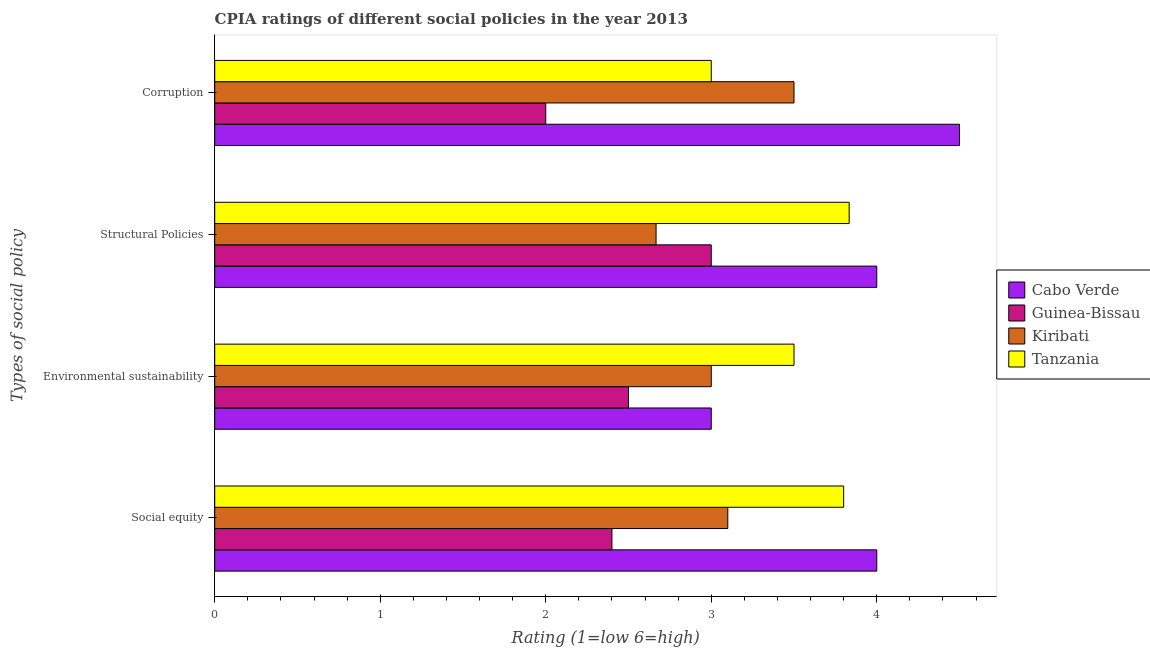Are the number of bars on each tick of the Y-axis equal?
Give a very brief answer. Yes. How many bars are there on the 2nd tick from the top?
Your answer should be very brief. 4. What is the label of the 2nd group of bars from the top?
Provide a succinct answer. Structural Policies. Across all countries, what is the minimum cpia rating of environmental sustainability?
Offer a terse response. 2.5. In which country was the cpia rating of social equity maximum?
Your answer should be compact. Cabo Verde. In which country was the cpia rating of structural policies minimum?
Provide a succinct answer. Kiribati. What is the total cpia rating of structural policies in the graph?
Your answer should be very brief. 13.5. What is the difference between the cpia rating of corruption in Kiribati and that in Cabo Verde?
Provide a succinct answer. -1. What is the difference between the cpia rating of environmental sustainability in Tanzania and the cpia rating of social equity in Guinea-Bissau?
Your response must be concise. 1.1. What is the average cpia rating of structural policies per country?
Your response must be concise. 3.37. What is the difference between the cpia rating of structural policies and cpia rating of social equity in Kiribati?
Offer a terse response. -0.43. What is the ratio of the cpia rating of social equity in Kiribati to that in Tanzania?
Your answer should be very brief. 0.82. What is the difference between the highest and the second highest cpia rating of structural policies?
Keep it short and to the point. 0.17. What is the difference between the highest and the lowest cpia rating of structural policies?
Offer a terse response. 1.33. Is the sum of the cpia rating of social equity in Cabo Verde and Kiribati greater than the maximum cpia rating of corruption across all countries?
Your answer should be very brief. Yes. Is it the case that in every country, the sum of the cpia rating of corruption and cpia rating of environmental sustainability is greater than the sum of cpia rating of structural policies and cpia rating of social equity?
Make the answer very short. No. What does the 2nd bar from the top in Social equity represents?
Offer a very short reply. Kiribati. What does the 3rd bar from the bottom in Structural Policies represents?
Your answer should be very brief. Kiribati. Are all the bars in the graph horizontal?
Ensure brevity in your answer.  Yes. Are the values on the major ticks of X-axis written in scientific E-notation?
Your response must be concise. No. Does the graph contain any zero values?
Your response must be concise. No. Does the graph contain grids?
Make the answer very short. No. How many legend labels are there?
Offer a terse response. 4. How are the legend labels stacked?
Make the answer very short. Vertical. What is the title of the graph?
Make the answer very short. CPIA ratings of different social policies in the year 2013. Does "Barbados" appear as one of the legend labels in the graph?
Keep it short and to the point. No. What is the label or title of the Y-axis?
Your answer should be very brief. Types of social policy. What is the Rating (1=low 6=high) in Kiribati in Social equity?
Give a very brief answer. 3.1. What is the Rating (1=low 6=high) of Guinea-Bissau in Environmental sustainability?
Provide a short and direct response. 2.5. What is the Rating (1=low 6=high) in Tanzania in Environmental sustainability?
Ensure brevity in your answer.  3.5. What is the Rating (1=low 6=high) in Cabo Verde in Structural Policies?
Offer a very short reply. 4. What is the Rating (1=low 6=high) in Kiribati in Structural Policies?
Give a very brief answer. 2.67. What is the Rating (1=low 6=high) of Tanzania in Structural Policies?
Give a very brief answer. 3.83. What is the Rating (1=low 6=high) in Guinea-Bissau in Corruption?
Your answer should be very brief. 2. What is the Rating (1=low 6=high) in Tanzania in Corruption?
Ensure brevity in your answer.  3. Across all Types of social policy, what is the maximum Rating (1=low 6=high) of Cabo Verde?
Offer a terse response. 4.5. Across all Types of social policy, what is the maximum Rating (1=low 6=high) of Guinea-Bissau?
Your answer should be compact. 3. Across all Types of social policy, what is the maximum Rating (1=low 6=high) in Tanzania?
Offer a very short reply. 3.83. Across all Types of social policy, what is the minimum Rating (1=low 6=high) in Cabo Verde?
Keep it short and to the point. 3. Across all Types of social policy, what is the minimum Rating (1=low 6=high) of Kiribati?
Your response must be concise. 2.67. Across all Types of social policy, what is the minimum Rating (1=low 6=high) in Tanzania?
Your answer should be compact. 3. What is the total Rating (1=low 6=high) in Cabo Verde in the graph?
Offer a very short reply. 15.5. What is the total Rating (1=low 6=high) of Kiribati in the graph?
Provide a succinct answer. 12.27. What is the total Rating (1=low 6=high) in Tanzania in the graph?
Offer a very short reply. 14.13. What is the difference between the Rating (1=low 6=high) of Cabo Verde in Social equity and that in Environmental sustainability?
Provide a succinct answer. 1. What is the difference between the Rating (1=low 6=high) in Guinea-Bissau in Social equity and that in Environmental sustainability?
Provide a short and direct response. -0.1. What is the difference between the Rating (1=low 6=high) of Cabo Verde in Social equity and that in Structural Policies?
Your answer should be compact. 0. What is the difference between the Rating (1=low 6=high) in Guinea-Bissau in Social equity and that in Structural Policies?
Your answer should be very brief. -0.6. What is the difference between the Rating (1=low 6=high) in Kiribati in Social equity and that in Structural Policies?
Offer a terse response. 0.43. What is the difference between the Rating (1=low 6=high) of Tanzania in Social equity and that in Structural Policies?
Provide a short and direct response. -0.03. What is the difference between the Rating (1=low 6=high) in Kiribati in Social equity and that in Corruption?
Offer a terse response. -0.4. What is the difference between the Rating (1=low 6=high) of Guinea-Bissau in Environmental sustainability and that in Structural Policies?
Your answer should be compact. -0.5. What is the difference between the Rating (1=low 6=high) in Kiribati in Environmental sustainability and that in Structural Policies?
Your response must be concise. 0.33. What is the difference between the Rating (1=low 6=high) in Cabo Verde in Environmental sustainability and that in Corruption?
Make the answer very short. -1.5. What is the difference between the Rating (1=low 6=high) of Guinea-Bissau in Environmental sustainability and that in Corruption?
Your response must be concise. 0.5. What is the difference between the Rating (1=low 6=high) of Guinea-Bissau in Structural Policies and that in Corruption?
Keep it short and to the point. 1. What is the difference between the Rating (1=low 6=high) in Cabo Verde in Social equity and the Rating (1=low 6=high) in Guinea-Bissau in Environmental sustainability?
Your answer should be very brief. 1.5. What is the difference between the Rating (1=low 6=high) of Guinea-Bissau in Social equity and the Rating (1=low 6=high) of Kiribati in Environmental sustainability?
Your answer should be compact. -0.6. What is the difference between the Rating (1=low 6=high) in Kiribati in Social equity and the Rating (1=low 6=high) in Tanzania in Environmental sustainability?
Your answer should be very brief. -0.4. What is the difference between the Rating (1=low 6=high) in Cabo Verde in Social equity and the Rating (1=low 6=high) in Guinea-Bissau in Structural Policies?
Your response must be concise. 1. What is the difference between the Rating (1=low 6=high) in Cabo Verde in Social equity and the Rating (1=low 6=high) in Kiribati in Structural Policies?
Provide a succinct answer. 1.33. What is the difference between the Rating (1=low 6=high) in Cabo Verde in Social equity and the Rating (1=low 6=high) in Tanzania in Structural Policies?
Offer a very short reply. 0.17. What is the difference between the Rating (1=low 6=high) of Guinea-Bissau in Social equity and the Rating (1=low 6=high) of Kiribati in Structural Policies?
Provide a succinct answer. -0.27. What is the difference between the Rating (1=low 6=high) of Guinea-Bissau in Social equity and the Rating (1=low 6=high) of Tanzania in Structural Policies?
Keep it short and to the point. -1.43. What is the difference between the Rating (1=low 6=high) in Kiribati in Social equity and the Rating (1=low 6=high) in Tanzania in Structural Policies?
Provide a short and direct response. -0.73. What is the difference between the Rating (1=low 6=high) of Cabo Verde in Social equity and the Rating (1=low 6=high) of Guinea-Bissau in Corruption?
Give a very brief answer. 2. What is the difference between the Rating (1=low 6=high) in Cabo Verde in Social equity and the Rating (1=low 6=high) in Tanzania in Corruption?
Your answer should be compact. 1. What is the difference between the Rating (1=low 6=high) in Guinea-Bissau in Environmental sustainability and the Rating (1=low 6=high) in Kiribati in Structural Policies?
Keep it short and to the point. -0.17. What is the difference between the Rating (1=low 6=high) in Guinea-Bissau in Environmental sustainability and the Rating (1=low 6=high) in Tanzania in Structural Policies?
Make the answer very short. -1.33. What is the difference between the Rating (1=low 6=high) of Kiribati in Environmental sustainability and the Rating (1=low 6=high) of Tanzania in Structural Policies?
Provide a succinct answer. -0.83. What is the difference between the Rating (1=low 6=high) in Cabo Verde in Environmental sustainability and the Rating (1=low 6=high) in Kiribati in Corruption?
Offer a very short reply. -0.5. What is the difference between the Rating (1=low 6=high) of Cabo Verde in Structural Policies and the Rating (1=low 6=high) of Guinea-Bissau in Corruption?
Offer a terse response. 2. What is the average Rating (1=low 6=high) of Cabo Verde per Types of social policy?
Your answer should be compact. 3.88. What is the average Rating (1=low 6=high) of Guinea-Bissau per Types of social policy?
Provide a succinct answer. 2.48. What is the average Rating (1=low 6=high) in Kiribati per Types of social policy?
Offer a very short reply. 3.07. What is the average Rating (1=low 6=high) in Tanzania per Types of social policy?
Keep it short and to the point. 3.53. What is the difference between the Rating (1=low 6=high) in Cabo Verde and Rating (1=low 6=high) in Kiribati in Social equity?
Provide a short and direct response. 0.9. What is the difference between the Rating (1=low 6=high) of Cabo Verde and Rating (1=low 6=high) of Tanzania in Social equity?
Provide a short and direct response. 0.2. What is the difference between the Rating (1=low 6=high) of Guinea-Bissau and Rating (1=low 6=high) of Kiribati in Social equity?
Ensure brevity in your answer.  -0.7. What is the difference between the Rating (1=low 6=high) of Guinea-Bissau and Rating (1=low 6=high) of Tanzania in Social equity?
Give a very brief answer. -1.4. What is the difference between the Rating (1=low 6=high) in Kiribati and Rating (1=low 6=high) in Tanzania in Social equity?
Offer a very short reply. -0.7. What is the difference between the Rating (1=low 6=high) in Cabo Verde and Rating (1=low 6=high) in Tanzania in Environmental sustainability?
Ensure brevity in your answer.  -0.5. What is the difference between the Rating (1=low 6=high) of Guinea-Bissau and Rating (1=low 6=high) of Kiribati in Environmental sustainability?
Offer a terse response. -0.5. What is the difference between the Rating (1=low 6=high) in Kiribati and Rating (1=low 6=high) in Tanzania in Environmental sustainability?
Your answer should be compact. -0.5. What is the difference between the Rating (1=low 6=high) in Cabo Verde and Rating (1=low 6=high) in Guinea-Bissau in Structural Policies?
Give a very brief answer. 1. What is the difference between the Rating (1=low 6=high) in Cabo Verde and Rating (1=low 6=high) in Kiribati in Structural Policies?
Make the answer very short. 1.33. What is the difference between the Rating (1=low 6=high) in Guinea-Bissau and Rating (1=low 6=high) in Tanzania in Structural Policies?
Provide a succinct answer. -0.83. What is the difference between the Rating (1=low 6=high) of Kiribati and Rating (1=low 6=high) of Tanzania in Structural Policies?
Make the answer very short. -1.17. What is the difference between the Rating (1=low 6=high) in Cabo Verde and Rating (1=low 6=high) in Guinea-Bissau in Corruption?
Provide a succinct answer. 2.5. What is the difference between the Rating (1=low 6=high) in Cabo Verde and Rating (1=low 6=high) in Kiribati in Corruption?
Offer a terse response. 1. What is the difference between the Rating (1=low 6=high) in Cabo Verde and Rating (1=low 6=high) in Tanzania in Corruption?
Ensure brevity in your answer.  1.5. What is the difference between the Rating (1=low 6=high) of Guinea-Bissau and Rating (1=low 6=high) of Kiribati in Corruption?
Your answer should be very brief. -1.5. What is the difference between the Rating (1=low 6=high) of Guinea-Bissau and Rating (1=low 6=high) of Tanzania in Corruption?
Make the answer very short. -1. What is the difference between the Rating (1=low 6=high) of Kiribati and Rating (1=low 6=high) of Tanzania in Corruption?
Keep it short and to the point. 0.5. What is the ratio of the Rating (1=low 6=high) of Tanzania in Social equity to that in Environmental sustainability?
Provide a short and direct response. 1.09. What is the ratio of the Rating (1=low 6=high) of Kiribati in Social equity to that in Structural Policies?
Offer a terse response. 1.16. What is the ratio of the Rating (1=low 6=high) of Tanzania in Social equity to that in Structural Policies?
Keep it short and to the point. 0.99. What is the ratio of the Rating (1=low 6=high) in Cabo Verde in Social equity to that in Corruption?
Provide a succinct answer. 0.89. What is the ratio of the Rating (1=low 6=high) in Kiribati in Social equity to that in Corruption?
Your answer should be compact. 0.89. What is the ratio of the Rating (1=low 6=high) in Tanzania in Social equity to that in Corruption?
Make the answer very short. 1.27. What is the ratio of the Rating (1=low 6=high) of Cabo Verde in Environmental sustainability to that in Structural Policies?
Ensure brevity in your answer.  0.75. What is the ratio of the Rating (1=low 6=high) in Kiribati in Environmental sustainability to that in Structural Policies?
Provide a succinct answer. 1.12. What is the ratio of the Rating (1=low 6=high) in Guinea-Bissau in Environmental sustainability to that in Corruption?
Give a very brief answer. 1.25. What is the ratio of the Rating (1=low 6=high) of Kiribati in Environmental sustainability to that in Corruption?
Your response must be concise. 0.86. What is the ratio of the Rating (1=low 6=high) in Tanzania in Environmental sustainability to that in Corruption?
Provide a succinct answer. 1.17. What is the ratio of the Rating (1=low 6=high) in Cabo Verde in Structural Policies to that in Corruption?
Provide a succinct answer. 0.89. What is the ratio of the Rating (1=low 6=high) of Guinea-Bissau in Structural Policies to that in Corruption?
Your answer should be compact. 1.5. What is the ratio of the Rating (1=low 6=high) in Kiribati in Structural Policies to that in Corruption?
Offer a terse response. 0.76. What is the ratio of the Rating (1=low 6=high) in Tanzania in Structural Policies to that in Corruption?
Keep it short and to the point. 1.28. What is the difference between the highest and the second highest Rating (1=low 6=high) of Cabo Verde?
Give a very brief answer. 0.5. What is the difference between the highest and the second highest Rating (1=low 6=high) of Guinea-Bissau?
Offer a terse response. 0.5. What is the difference between the highest and the second highest Rating (1=low 6=high) of Kiribati?
Provide a short and direct response. 0.4. What is the difference between the highest and the lowest Rating (1=low 6=high) of Kiribati?
Provide a succinct answer. 0.83. 